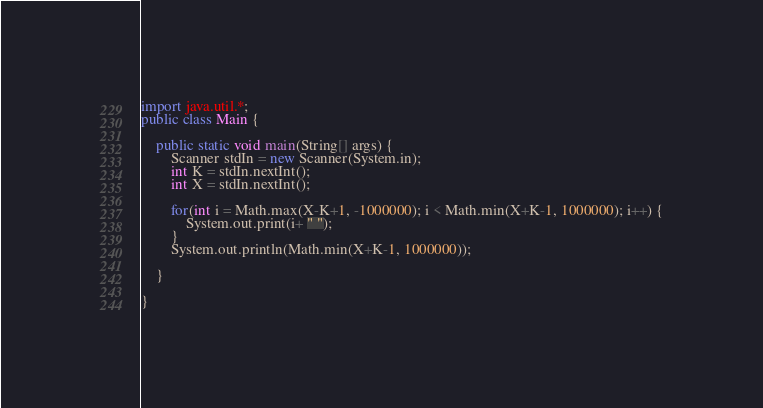<code> <loc_0><loc_0><loc_500><loc_500><_Java_>import java.util.*;
public class Main {

	public static void main(String[] args) {
		Scanner stdIn = new Scanner(System.in);
		int K = stdIn.nextInt();
		int X = stdIn.nextInt();
		
		for(int i = Math.max(X-K+1, -1000000); i < Math.min(X+K-1, 1000000); i++) {
			System.out.print(i+ " ");
		}
		System.out.println(Math.min(X+K-1, 1000000));

	}

}</code> 